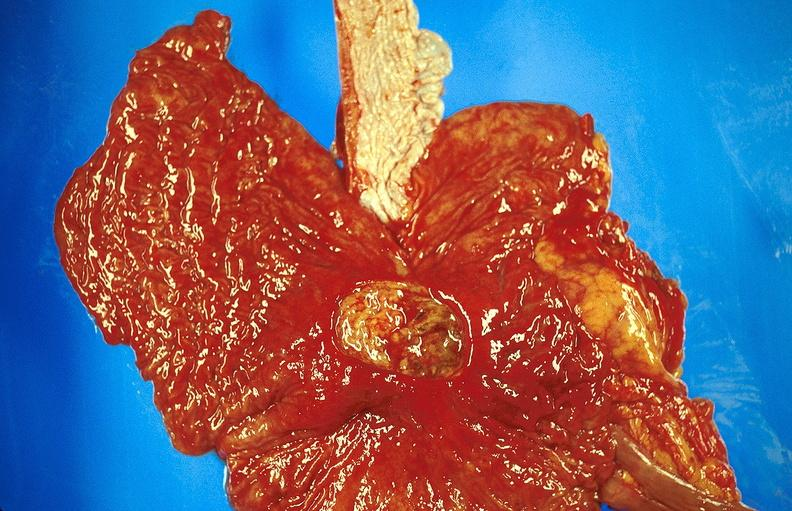what does this image show?
Answer the question using a single word or phrase. Gastric ulcer 